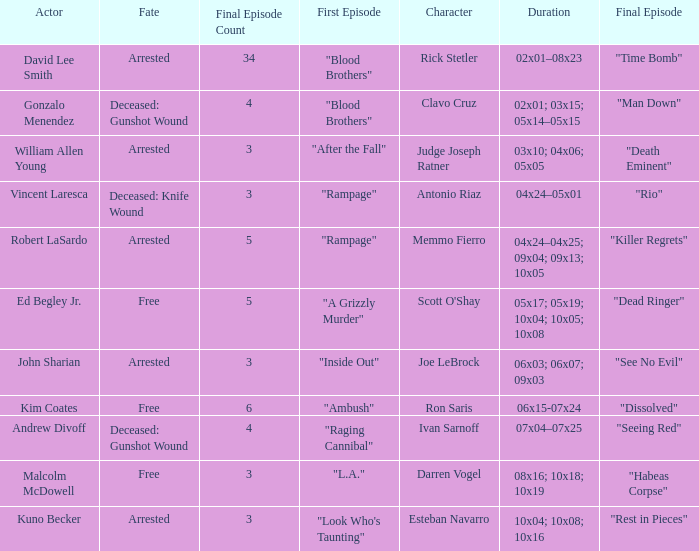Which character meets their demise through a knife wound in their fate? Antonio Riaz. 